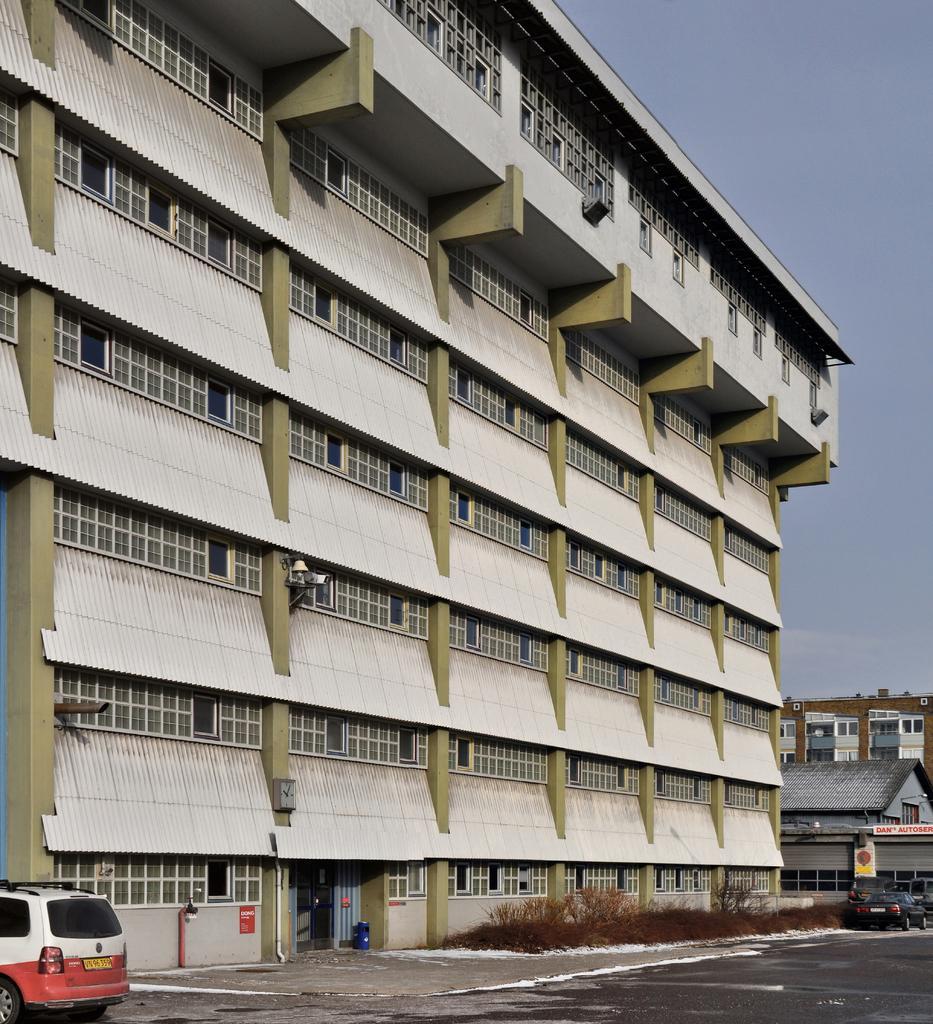Describe this image in one or two sentences. In this picture I can see buildings and couple of cars and I can see few plants and a blue sky. 